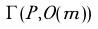<formula> <loc_0><loc_0><loc_500><loc_500>\Gamma ( P , O ( m ) )</formula> 